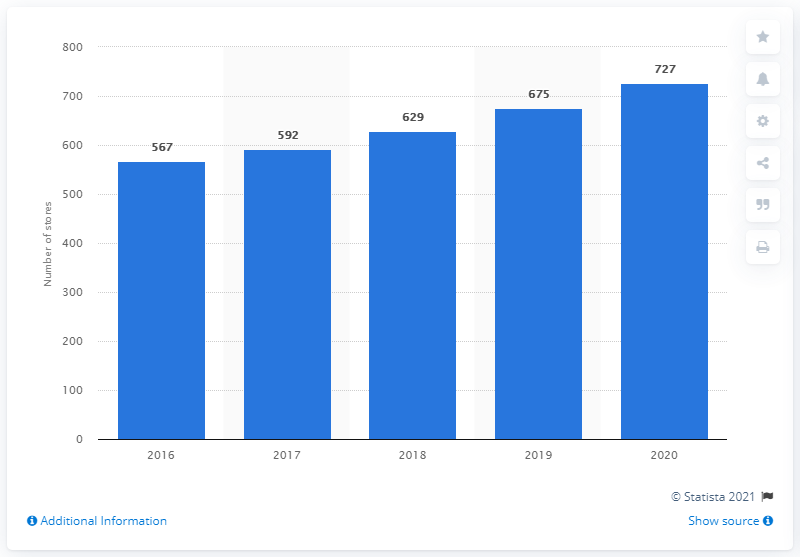List a handful of essential elements in this visual. As of February 2020, Burlington had operated 727 stores. 